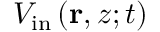<formula> <loc_0><loc_0><loc_500><loc_500>V _ { i n } \left ( r , z ; t \right )</formula> 